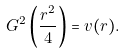Convert formula to latex. <formula><loc_0><loc_0><loc_500><loc_500>\ G ^ { 2 } \left ( \frac { r ^ { 2 } } { 4 } \right ) = v ( r ) .</formula> 